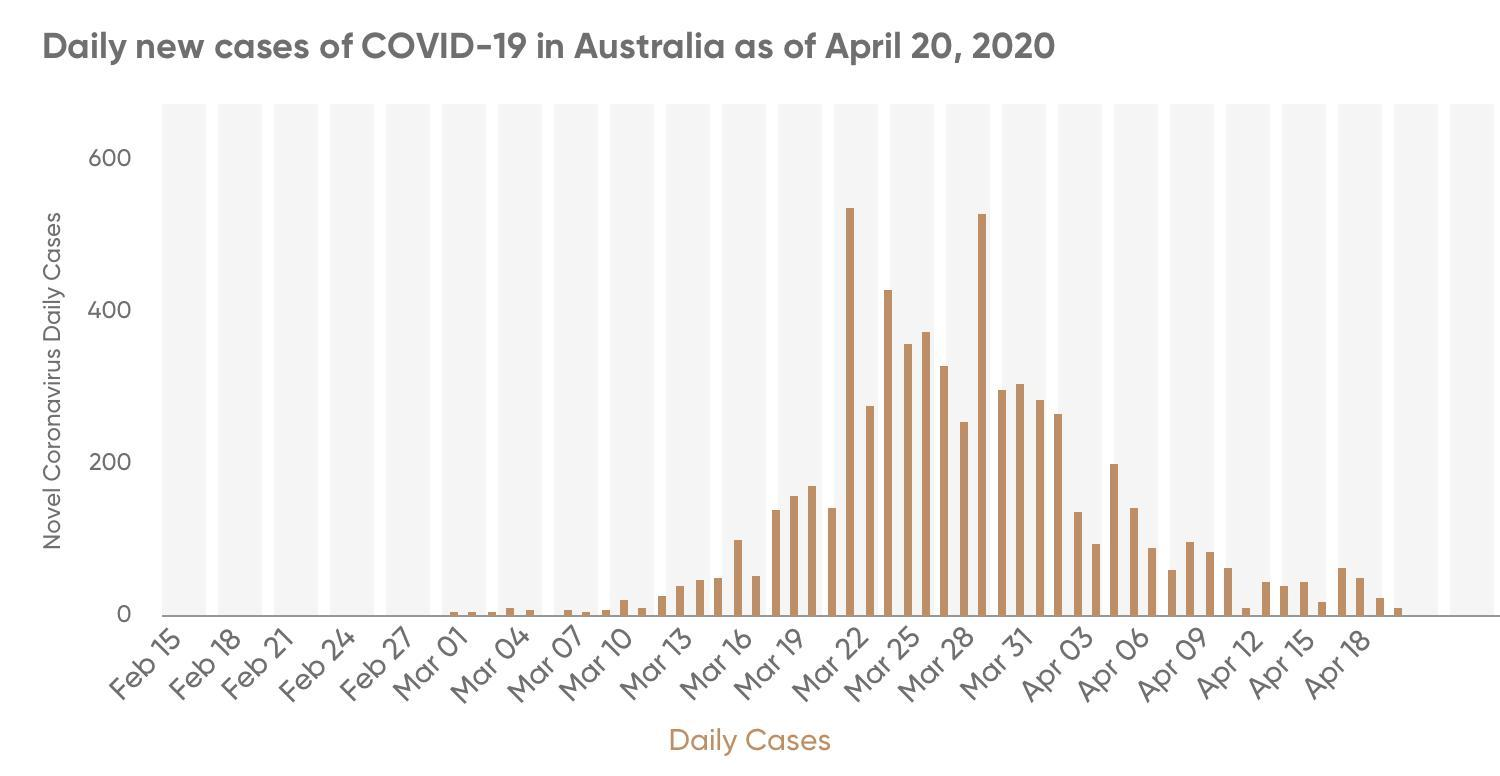On which date was Covid -19 first reported in Australia?
Answer the question with a short phrase. Mar 01 